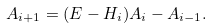<formula> <loc_0><loc_0><loc_500><loc_500>A _ { i + 1 } = ( E - H _ { i } ) A _ { i } - A _ { i - 1 } .</formula> 